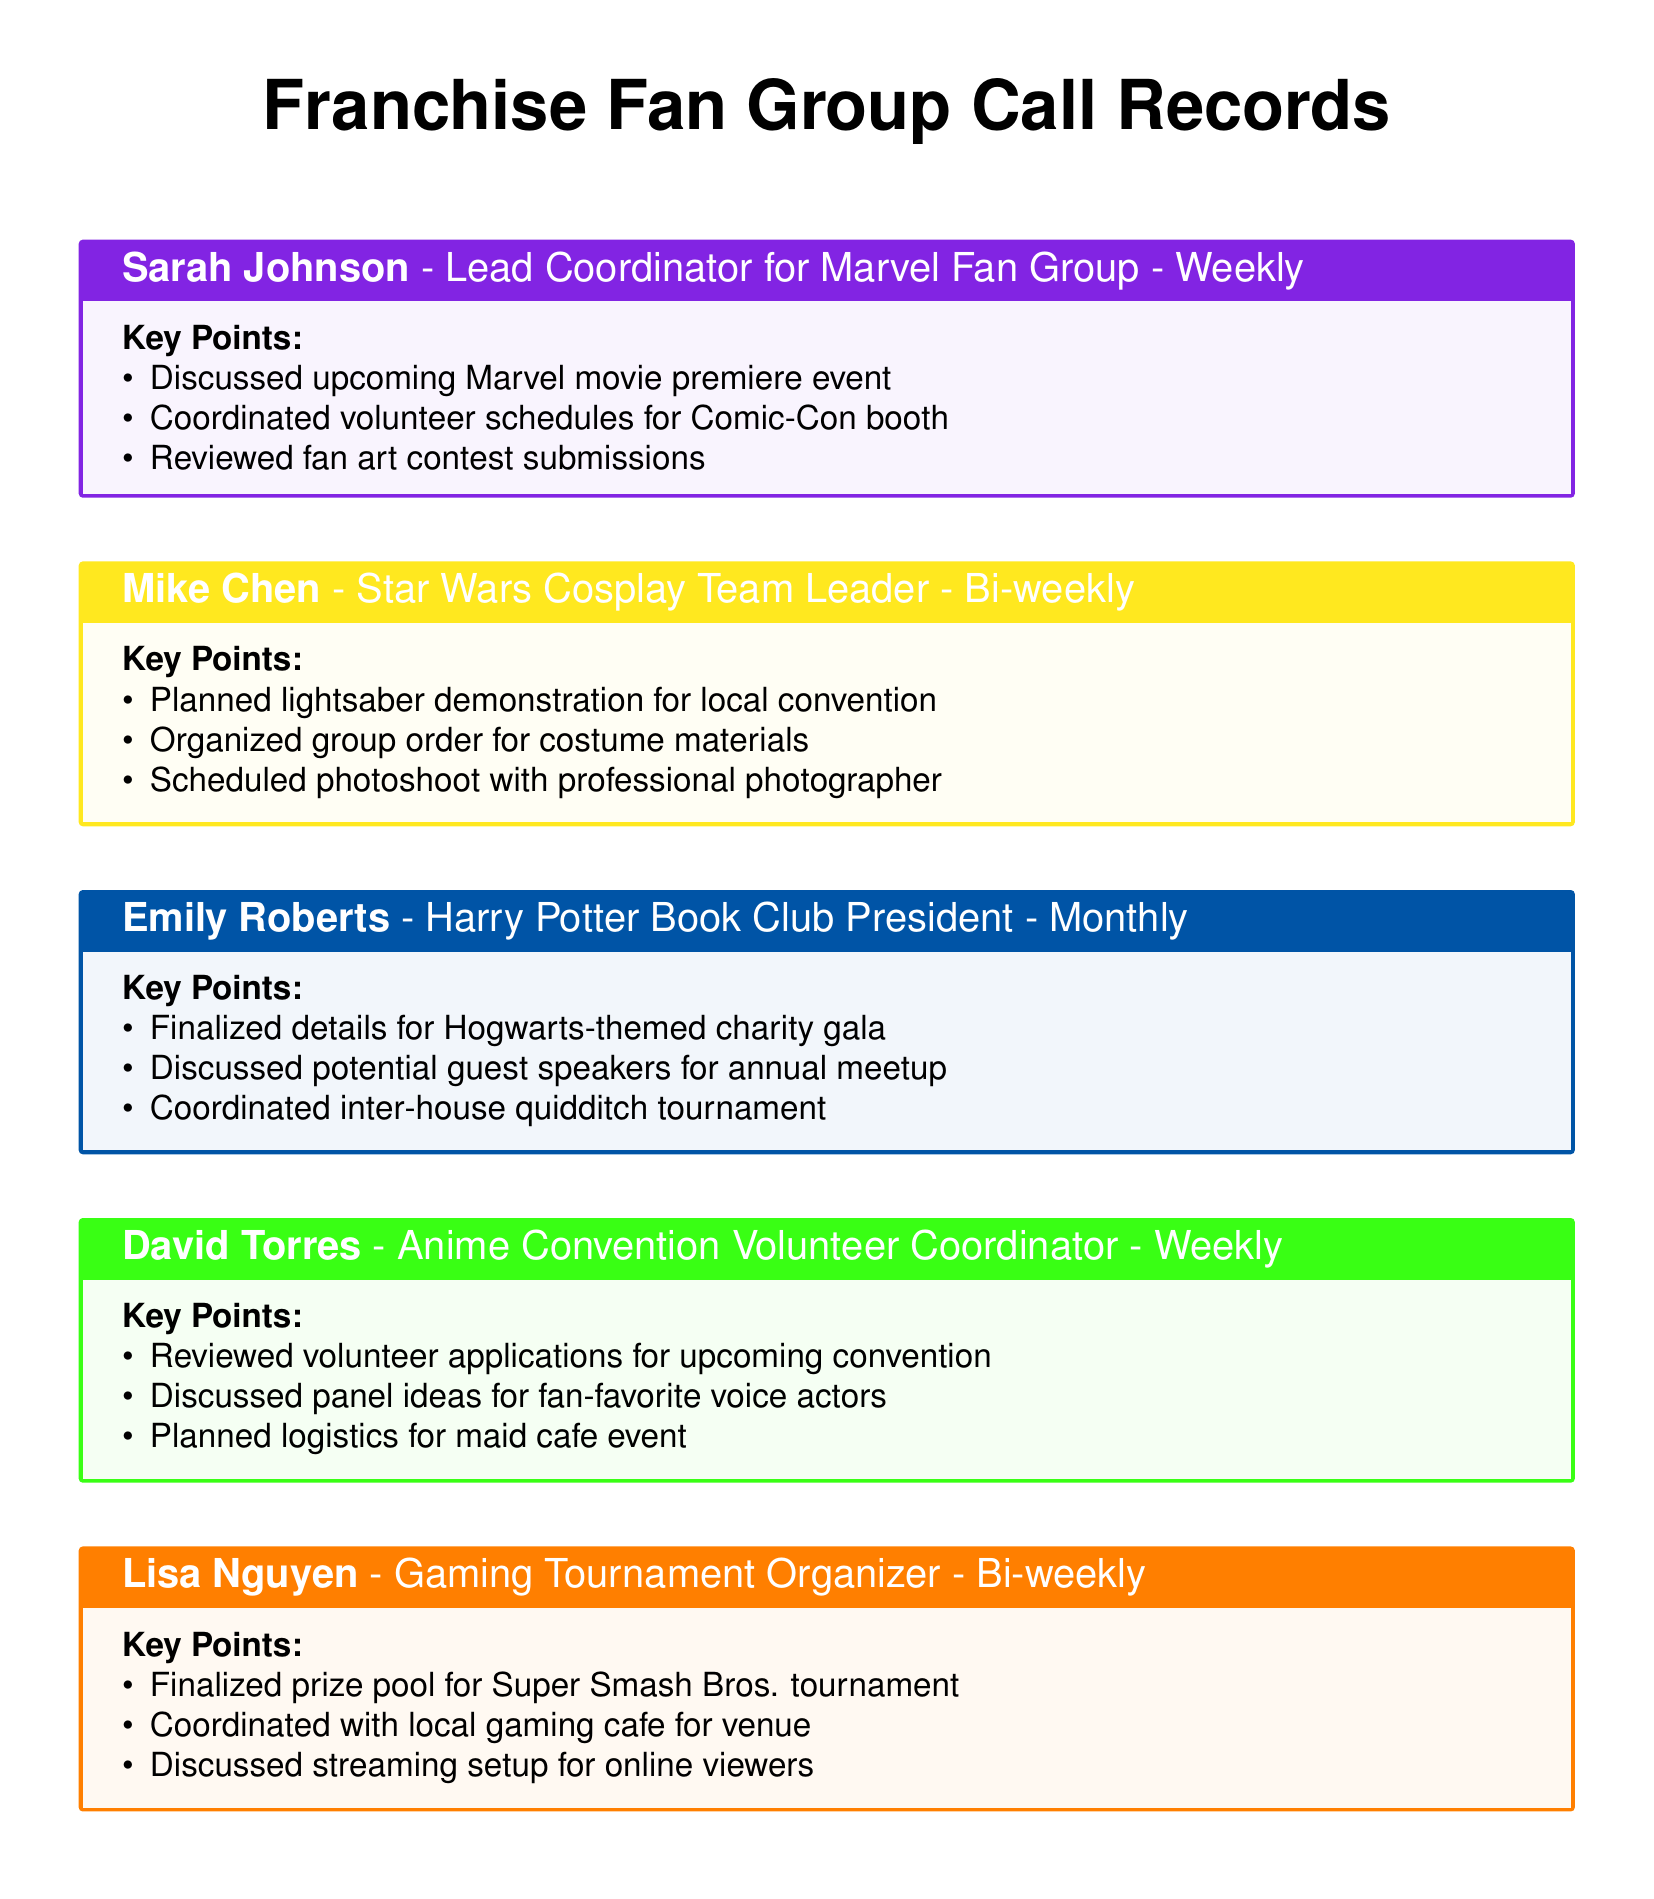What is the name of the lead coordinator for the Marvel Fan Group? The document states that Sarah Johnson is the Lead Coordinator for the Marvel Fan Group.
Answer: Sarah Johnson How often does Mike Chen hold meetings? The document indicates that Mike Chen has bi-weekly meetings as a Star Wars Cosplay Team Leader.
Answer: Bi-weekly What event did Emily Roberts finalize details for? According to the document, Emily Roberts finalized details for a Hogwarts-themed charity gala.
Answer: Hogwarts-themed charity gala Who is the volunteer coordinator for the Anime Convention? The document identifies David Torres as the Anime Convention Volunteer Coordinator.
Answer: David Torres What was discussed in the latest call with Lisa Nguyen? The document reflects that Lisa Nguyen discussed the prize pool for the Super Smash Bros. tournament in her latest call.
Answer: Prize pool for Super Smash Bros. tournament How many key points are mentioned for the Marvel Fan Group? The document shows that there are three key points listed for the Marvel Fan Group's call.
Answer: Three What type of event is planned by the gaming tournament organizer? The document mentions that Lisa Nguyen is organizing a super smash bros. tournament.
Answer: Super Smash Bros. tournament Which fan group holds a monthly meeting? The document indicates that the Harry Potter Book Club meets monthly.
Answer: Harry Potter Book Club What color code is used for the Star Wars contact box? The document specifies that the color code for the Star Wars contact box is yellow.
Answer: Yellow 